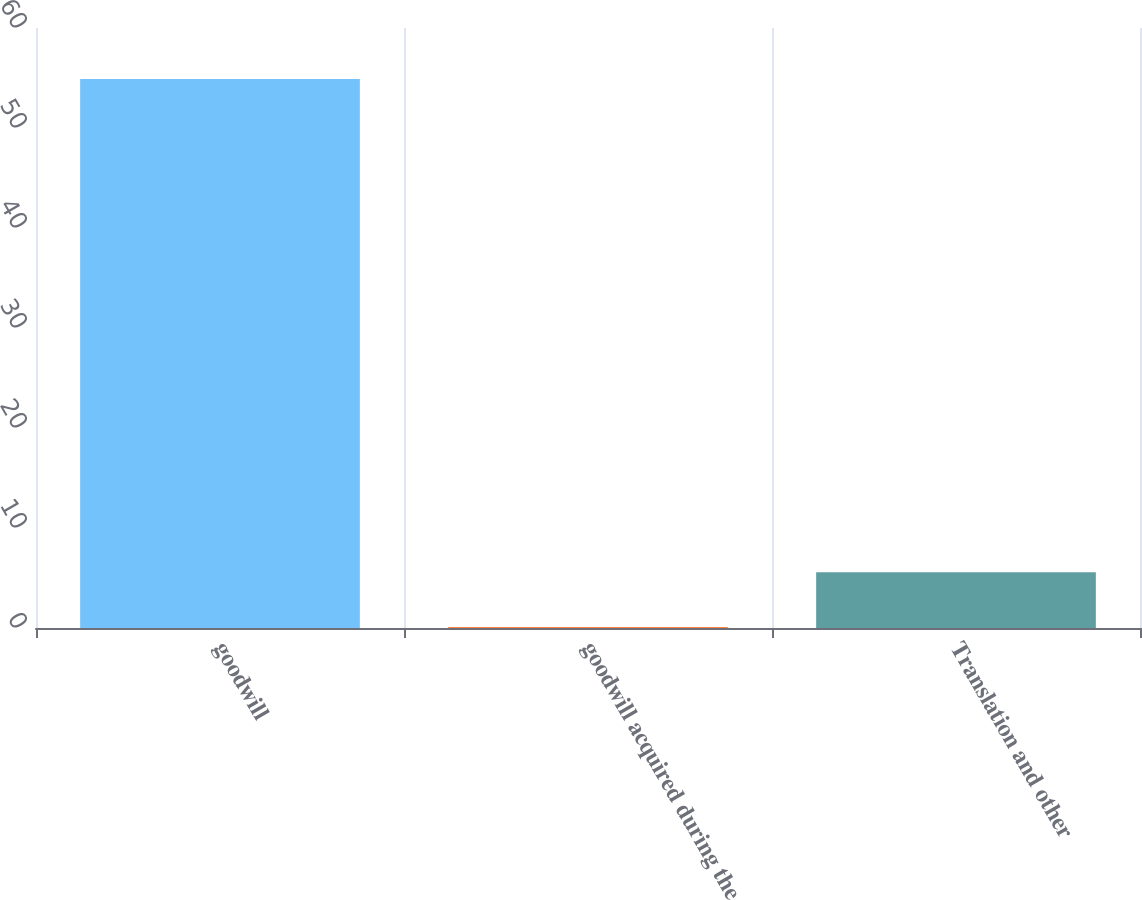<chart> <loc_0><loc_0><loc_500><loc_500><bar_chart><fcel>goodwill<fcel>goodwill acquired during the<fcel>Translation and other<nl><fcel>54.9<fcel>0.1<fcel>5.58<nl></chart> 